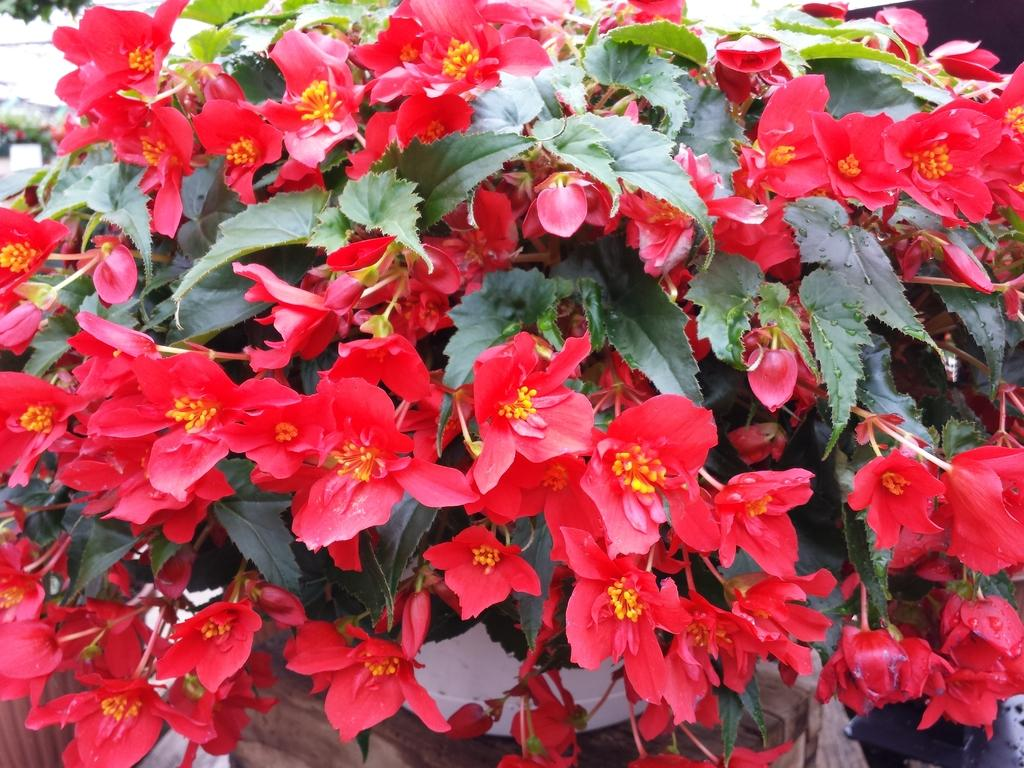What type of plants can be seen in the image? There are flowers and a tree in the image. Can you describe the tree in the image? The tree in the image is a distinct feature, but no specific details about its appearance are provided. How many types of plants are visible in the image? There are two types of plants visible in the image: flowers and a tree. How many oranges are hanging from the tree in the image? There are no oranges present in the image; it only features flowers and a tree. What type of ant can be seen crawling on the flowers in the image? There are no ants present in the image; it only features flowers and a tree. 